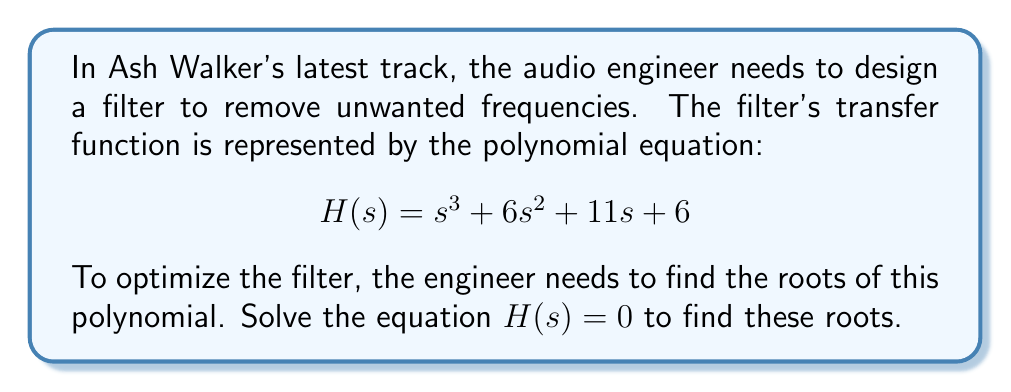Help me with this question. To solve this polynomial equation, we'll use the following steps:

1) First, let's check if there are any rational roots using the rational root theorem. The possible rational roots are the factors of the constant term: ±1, ±2, ±3, ±6.

2) Testing these values, we find that $s = -1$ is a root. Dividing the polynomial by $(s+1)$:

   $$(s^3 + 6s^2 + 11s + 6) = (s+1)(s^2 + 5s + 6)$$

3) Now we have a quadratic equation to solve: $s^2 + 5s + 6 = 0$

4) We can solve this using the quadratic formula: $s = \frac{-b \pm \sqrt{b^2 - 4ac}}{2a}$

   Where $a=1$, $b=5$, and $c=6$

5) Substituting these values:

   $$s = \frac{-5 \pm \sqrt{5^2 - 4(1)(6)}}{2(1)} = \frac{-5 \pm \sqrt{25 - 24}}{2} = \frac{-5 \pm 1}{2}$$

6) This gives us two more roots:

   $$s = \frac{-5 + 1}{2} = -2$$ and $$s = \frac{-5 - 1}{2} = -3$$

Therefore, the three roots of the polynomial are $s = -1$, $s = -2$, and $s = -3$.
Answer: The roots of the polynomial $H(s) = s^3 + 6s^2 + 11s + 6$ are $s = -1$, $s = -2$, and $s = -3$. 